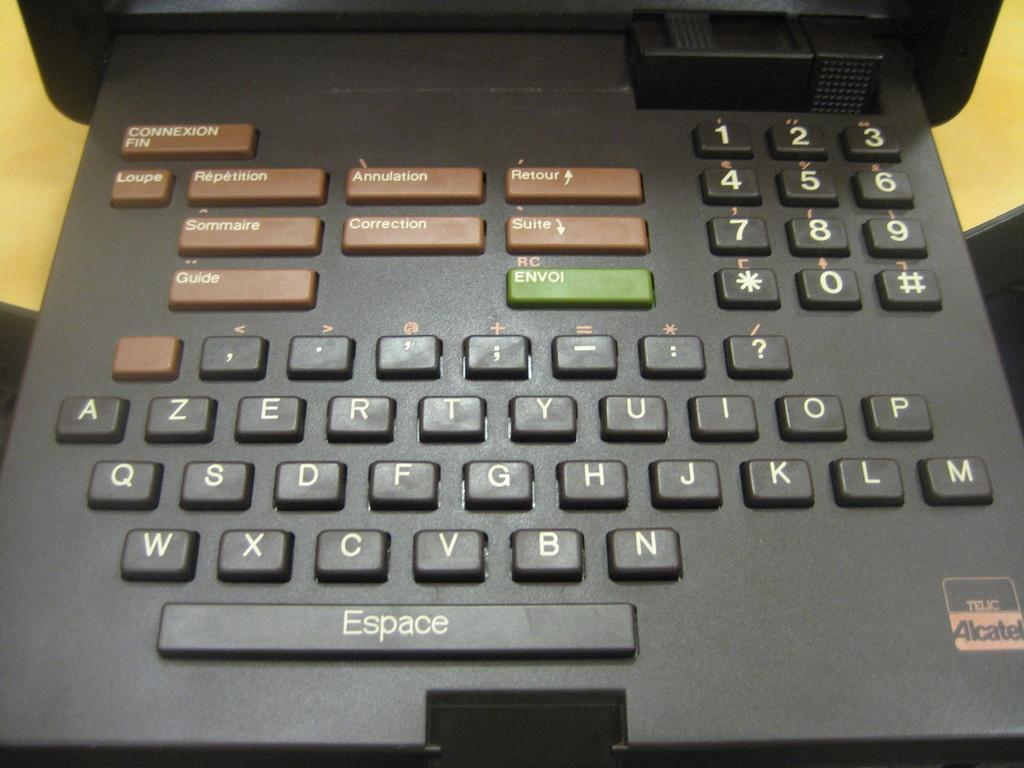Provide a one-sentence caption for the provided image. A small electronic keyboard has a space bar labeled Espace. 